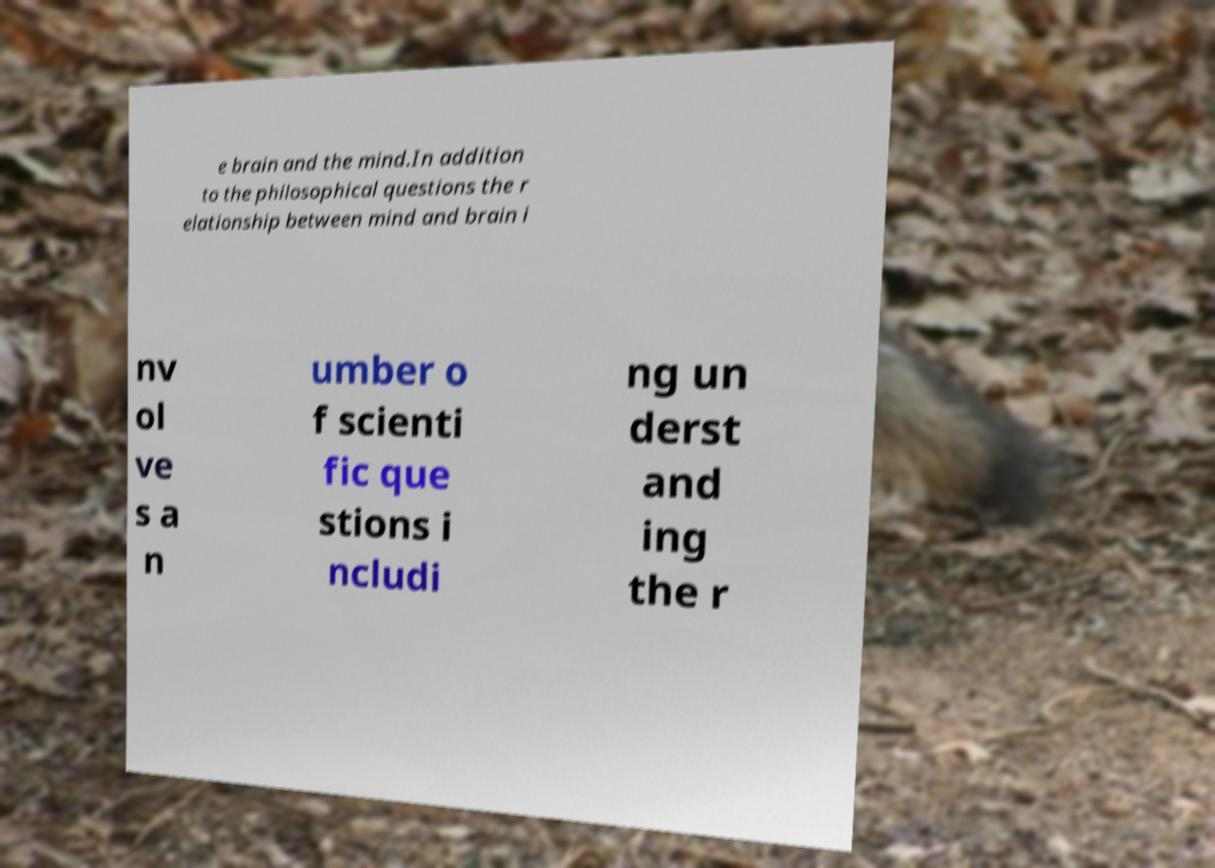Please read and relay the text visible in this image. What does it say? e brain and the mind.In addition to the philosophical questions the r elationship between mind and brain i nv ol ve s a n umber o f scienti fic que stions i ncludi ng un derst and ing the r 